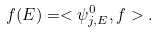Convert formula to latex. <formula><loc_0><loc_0><loc_500><loc_500>f ( E ) = < \psi _ { j , E } ^ { 0 } , f > .</formula> 